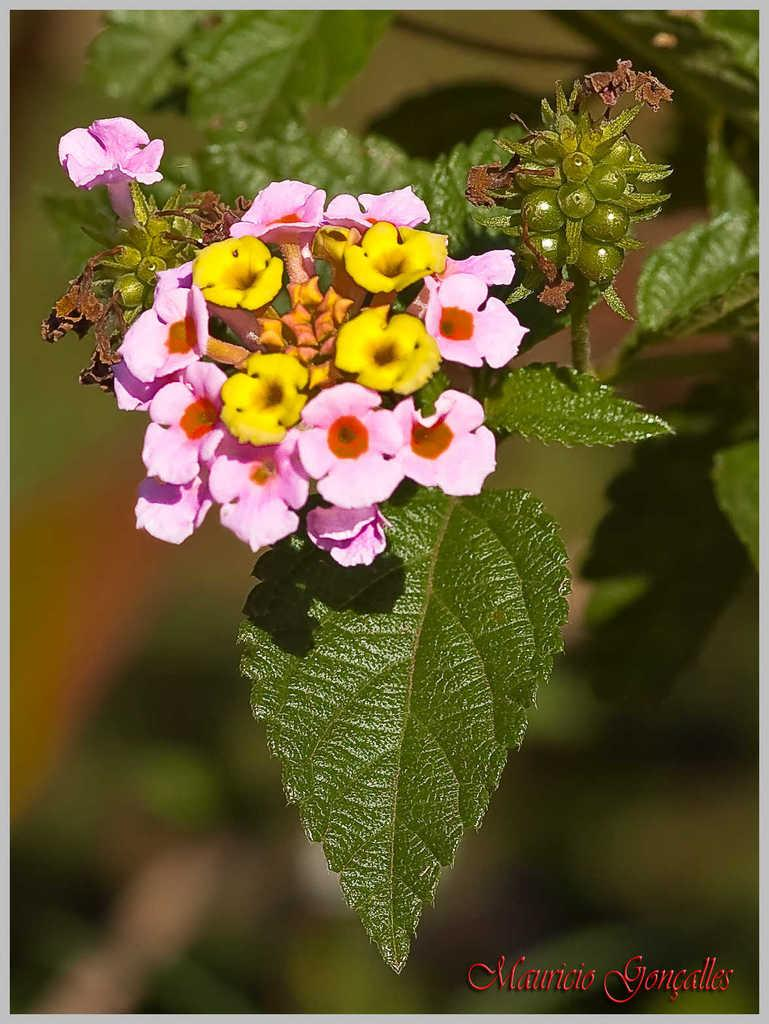What type of plants can be seen in the image? There are flowers and leaves in the image. What can be observed about the background of the image? The background of the image is blurred. Reasoning: Let's think step by identifying the main subjects and objects in the image based on the provided facts. We then formulate questions that focus on the location and characteristics of these subjects and objects, ensuring that each question can be answered definitively with the information given. We avoid yes/no questions and ensure that the language is simple and clear. Absurd Question/Answer: What type of lettuce is being used as apparel in the image? There is no lettuce or apparel present in the image; it features flowers and leaves. How does the image start, and what is the first thing that happens in it? The image does not have a start or any action taking place; it is a still image of flowers and leaves. 